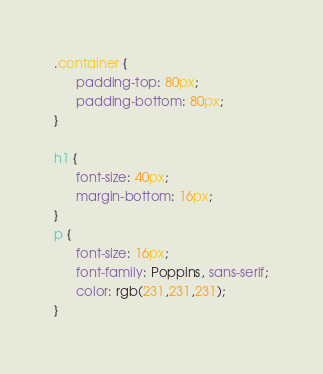Convert code to text. <code><loc_0><loc_0><loc_500><loc_500><_CSS_>.container {
      padding-top: 80px; 
      padding-bottom: 80px;
}

h1 {
      font-size: 40px; 
      margin-bottom: 16px;
}
p {
      font-size: 16px;
      font-family: Poppins, sans-serif;
      color: rgb(231,231,231);
}
</code> 